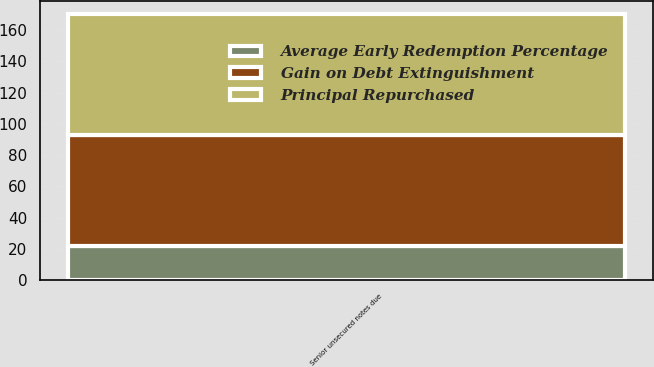<chart> <loc_0><loc_0><loc_500><loc_500><stacked_bar_chart><ecel><fcel>Senior unsecured notes due<nl><fcel>Gain on Debt Extinguishment<fcel>71<nl><fcel>Principal Repurchased<fcel>77.02<nl><fcel>Average Early Redemption Percentage<fcel>22<nl></chart> 